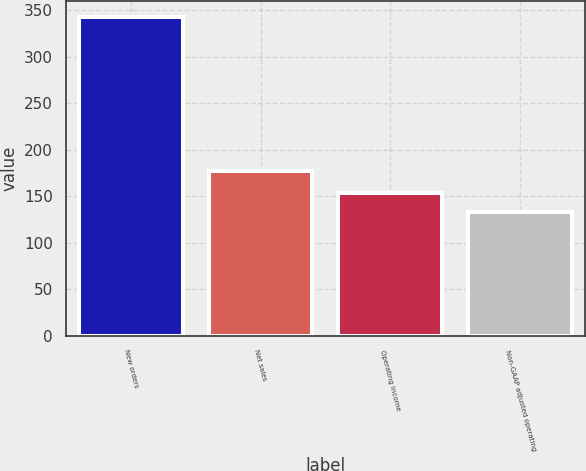Convert chart to OTSL. <chart><loc_0><loc_0><loc_500><loc_500><bar_chart><fcel>New orders<fcel>Net sales<fcel>Operating income<fcel>Non-GAAP adjusted operating<nl><fcel>343<fcel>177<fcel>154<fcel>133<nl></chart> 